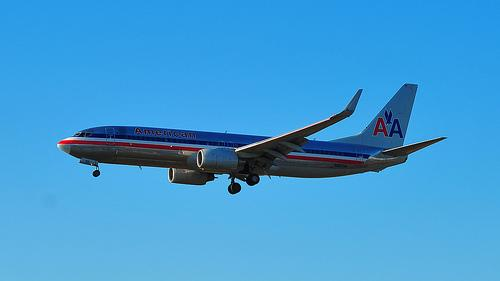Give a brief overview of the image focusing on the status of the airplane. The American Airlines plane is flying in the sky with its landing gear extended and two engines visible. Describe the airplane's main components visible in the image. The airplane features two jet engines, an extended landing gear, and the recognizable American Airlines logo on its tail. Mention the setting of the image and describe the airplane in it. In a clear blue sky, an American Airlines plane flies gracefully with its landing gear extended and engines visible. Describe the scene in the image with a focus on the sky. The sky is a clear, cloud-free blue, providing a perfect backdrop for the American Airlines plane flying through it. Provide an overview of the main elements in the image. An American Airlines plane is flying in a clear blue sky with its landing gear in motion, visible engines, and the airline's logo on the tail section. Briefly describe the airplane in the image. The airplane has American Airlines branding, two engines, a visible landing gear, and is soaring through the blue sky. Write a sentence describing the image with emphasis on the airline company. An American Airlines aircraft soars through the clear blue sky, showcasing its classic branding and engineering. Mention three features unique to the aircraft in the image. The aircraft has American Airlines logo on its tail, two jet engines, and an extended landing gear. Imagine you're describing the image to someone who cannot see it. What would you mention? I'd describe a cloud-free blue sky in which an American Airlines plane is flying. The aircraft's engines, landing gear, and the company logo are all visible. Narrate the image as if you were a witness to the scene. I saw an American Airlines plane soaring through the cloudless blue sky, its engines and landing gear clearly visible. 